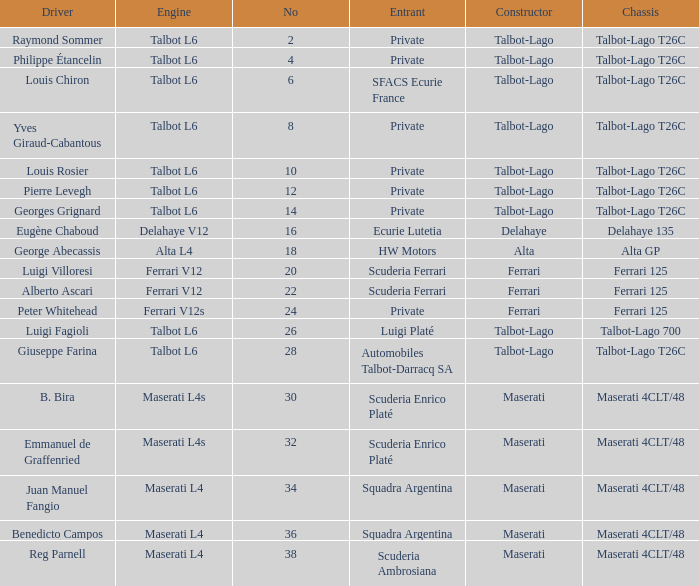Name the constructor for number 10 Talbot-Lago. 